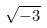Convert formula to latex. <formula><loc_0><loc_0><loc_500><loc_500>\sqrt { - 3 }</formula> 